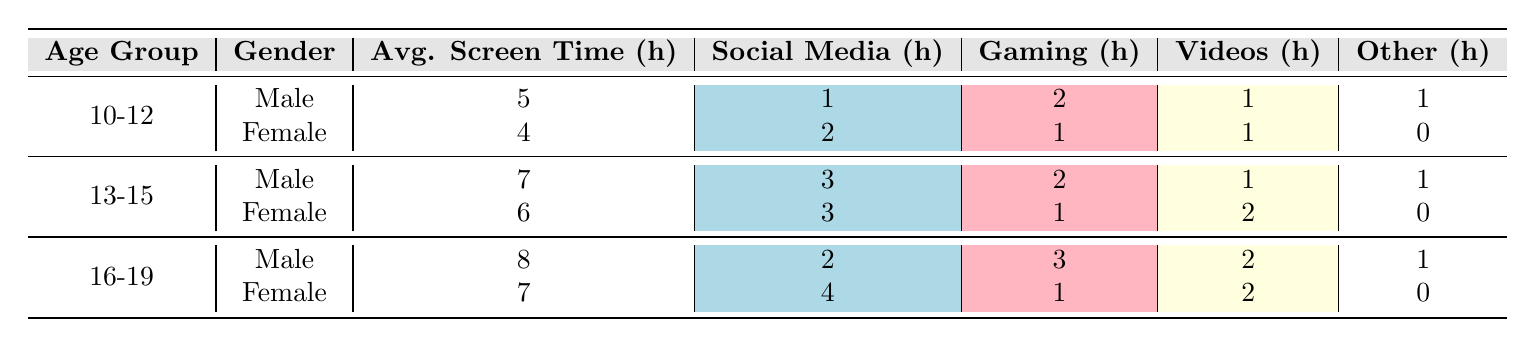What is the average screen time for males in the age group 10-12? The table shows that the average screen time for males in the age group 10-12 is listed as 5 hours.
Answer: 5 hours How much time do 13-15 year old females spend on social media? According to the table, females in the age group 13-15 spend an average of 3 hours on social media.
Answer: 3 hours Which gender in the age group 16-19 has higher average screen time? The table shows that males in the age group 16-19 have an average screen time of 8 hours, while females have 7 hours. Thus, males have higher average screen time.
Answer: Male What is the total average screen time for 10-12 year old females? The table states that the average screen time for 10-12 year old females is 4 hours.
Answer: 4 hours Is the average screen time for 16-19 year old females less than that of 13-15 year old males? The average screen time for 16-19 year old females is 7 hours and for 13-15 year old males is 7 hours as well. Since they are equal, the statement is false.
Answer: No What is the difference in average screen time between males in the age group 16-19 and those in 10-12? Males in 16-19 have 8 hours of average screen time, while those in 10-12 have 5 hours. The difference is 8 - 5 = 3 hours.
Answer: 3 hours What is the average screen time for all males across all age groups combined? The average screen time for males is calculated by taking the sum (5 + 7 + 8) and dividing it by 3 (the number of groups): (5 + 7 + 8) = 20, therefore the average is 20 / 3 = approximately 6.67 hours.
Answer: 6.67 hours How many total hours do 13-15 year old females spend on gaming and videos combined? From the table, 13-15 year old females spend 1 hour on gaming and 2 hours on videos. The total is 1 + 2 = 3 hours.
Answer: 3 hours Which age group has the highest average screen time overall? By looking at the average screen times (5 for 10-12, 7 for 13-15, and 8 for 16-19), the age group 16-19 has the highest average screen time of 8 hours.
Answer: 16-19 